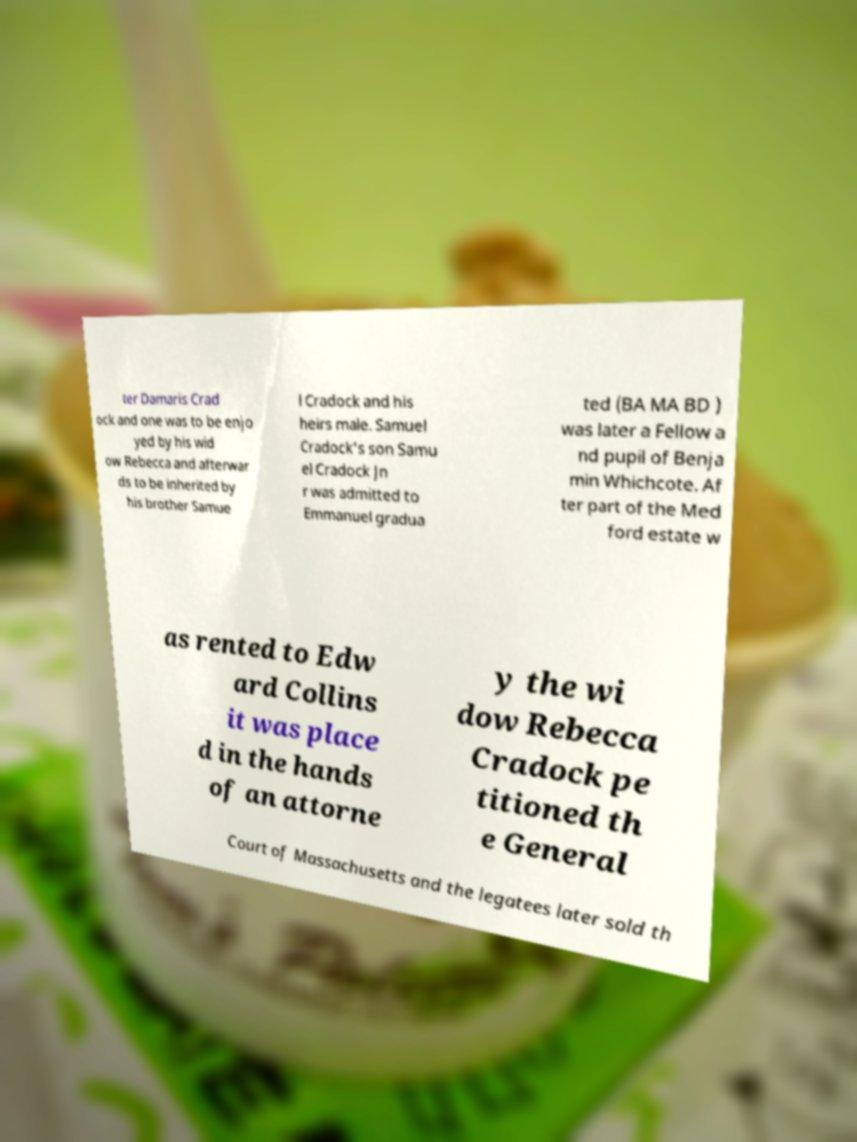Please read and relay the text visible in this image. What does it say? ter Damaris Crad ock and one was to be enjo yed by his wid ow Rebecca and afterwar ds to be inherited by his brother Samue l Cradock and his heirs male. Samuel Cradock's son Samu el Cradock Jn r was admitted to Emmanuel gradua ted (BA MA BD ) was later a Fellow a nd pupil of Benja min Whichcote. Af ter part of the Med ford estate w as rented to Edw ard Collins it was place d in the hands of an attorne y the wi dow Rebecca Cradock pe titioned th e General Court of Massachusetts and the legatees later sold th 